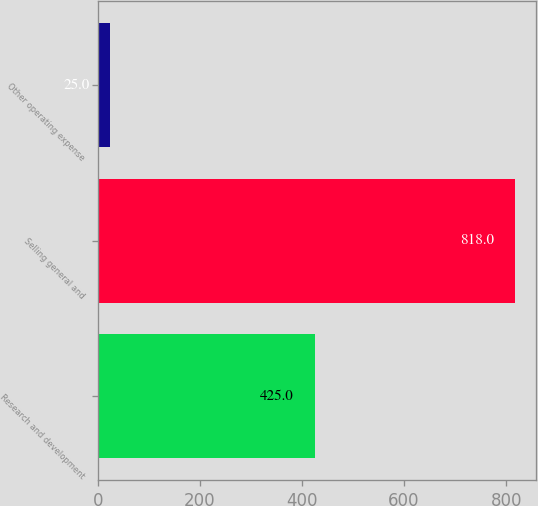Convert chart to OTSL. <chart><loc_0><loc_0><loc_500><loc_500><bar_chart><fcel>Research and development<fcel>Selling general and<fcel>Other operating expense<nl><fcel>425<fcel>818<fcel>25<nl></chart> 